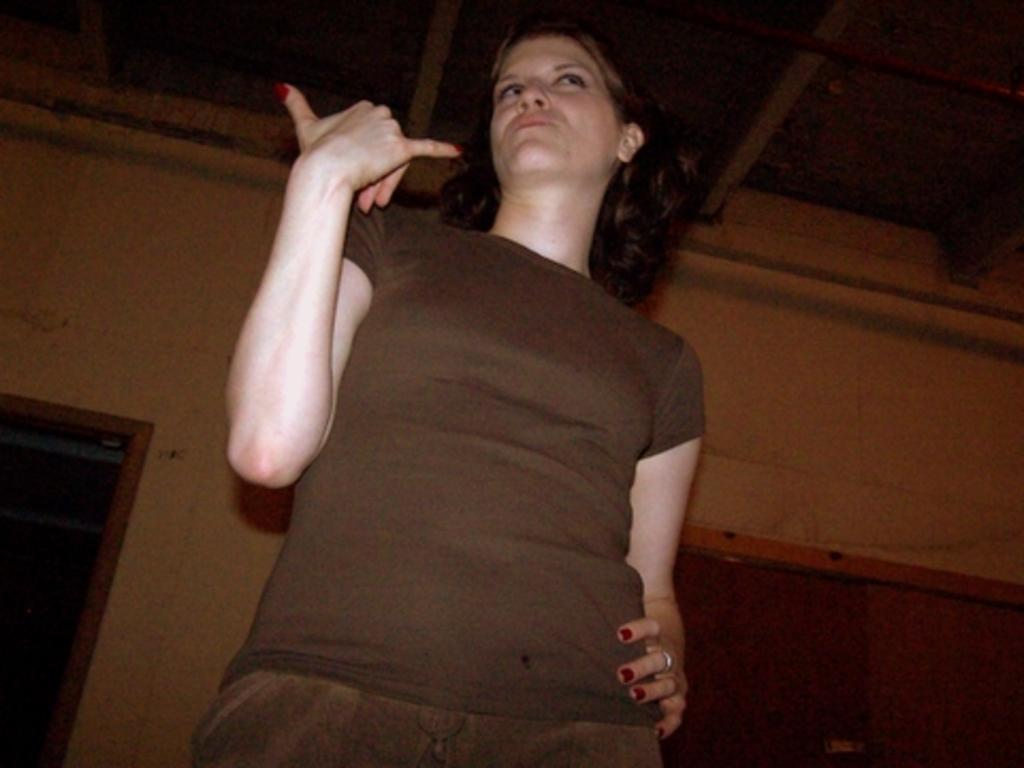What is the main subject in the image? There is a woman standing in the image. What can be seen behind the woman? There is a wall in the image. Is there any entrance or exit visible in the image? Yes, there is a door in the image. What is the rate of the bursting dress in the image? There is no dress present in the image, let alone a bursting one, so it is not possible to determine a rate. 